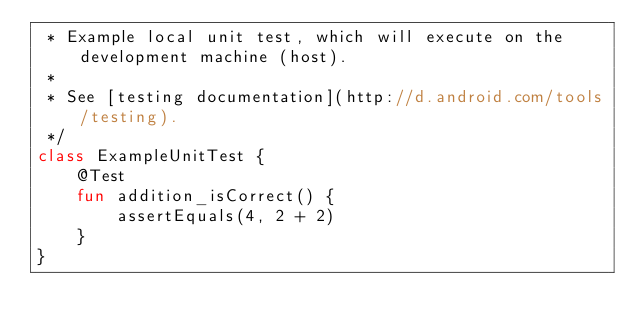Convert code to text. <code><loc_0><loc_0><loc_500><loc_500><_Kotlin_> * Example local unit test, which will execute on the development machine (host).
 *
 * See [testing documentation](http://d.android.com/tools/testing).
 */
class ExampleUnitTest {
    @Test
    fun addition_isCorrect() {
        assertEquals(4, 2 + 2)
    }
}</code> 